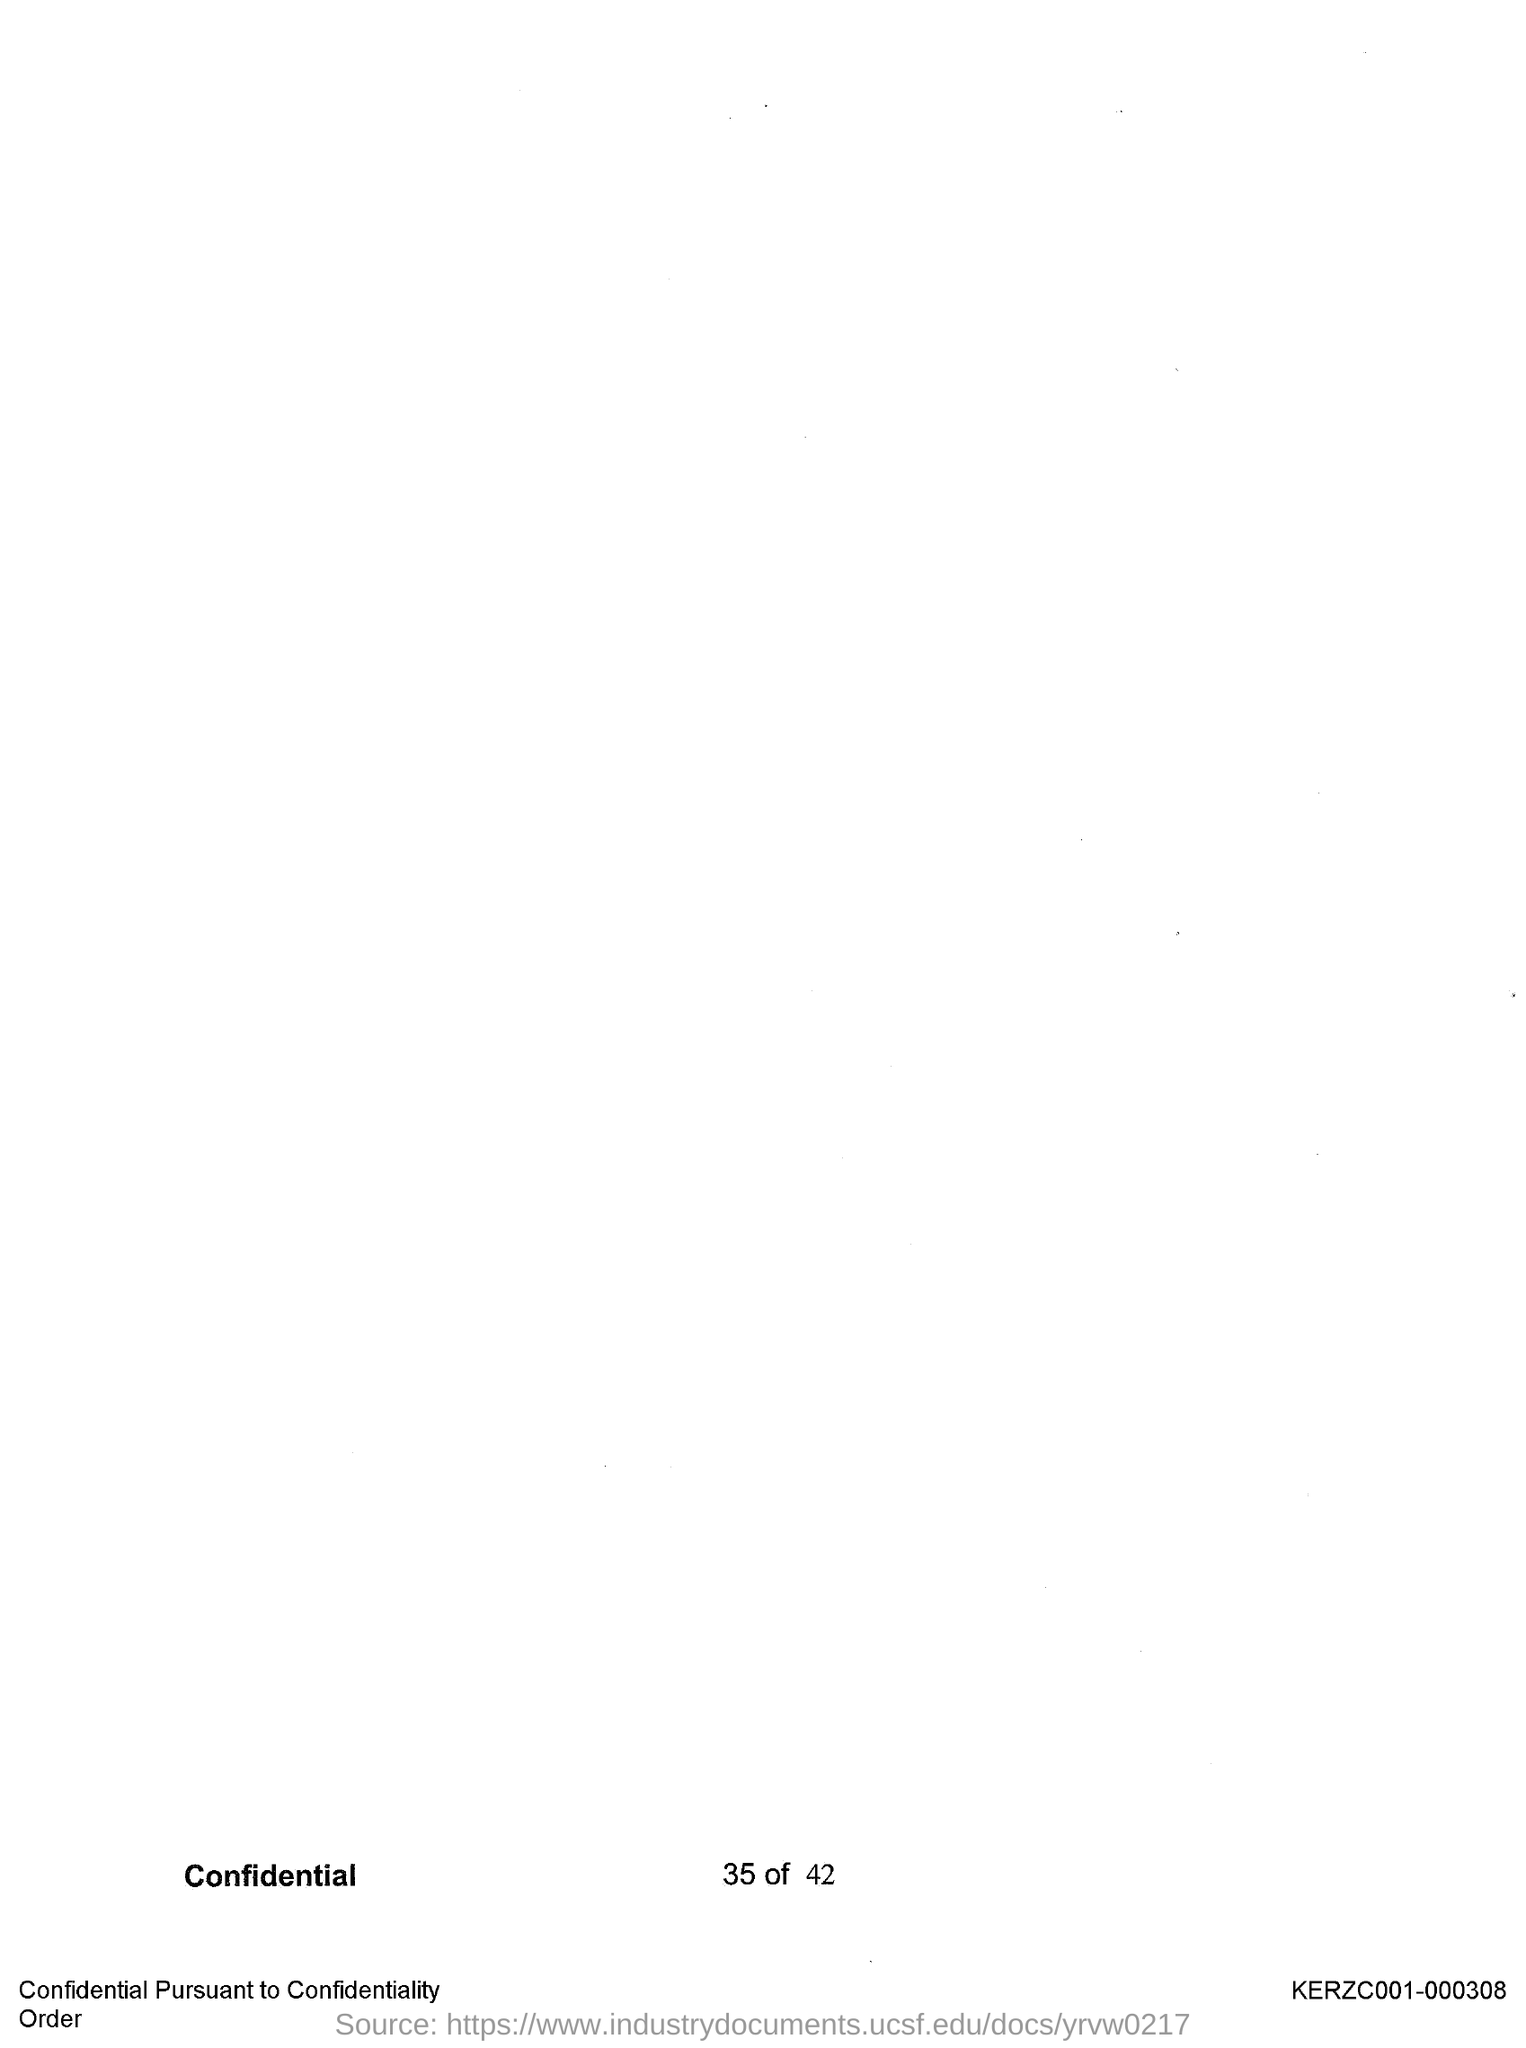What is the page no mentioned in this document?
Your answer should be very brief. 35. 